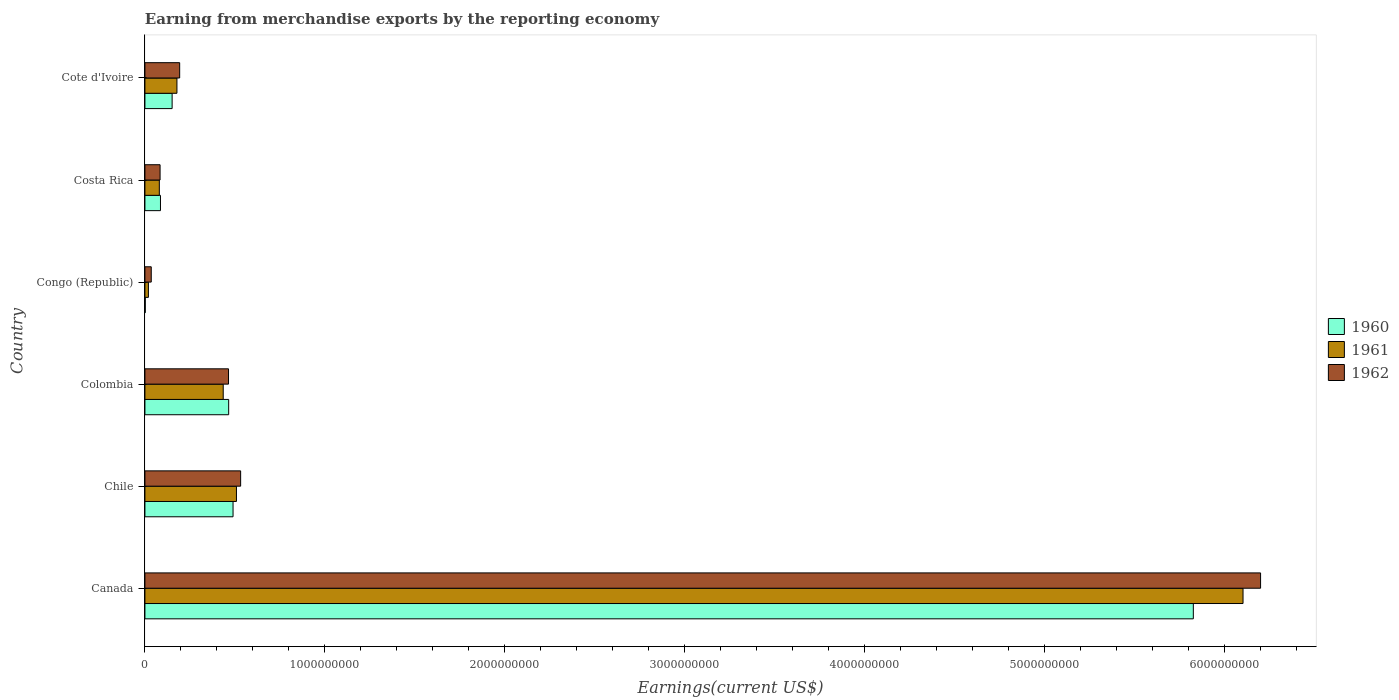How many different coloured bars are there?
Your answer should be very brief. 3. Are the number of bars on each tick of the Y-axis equal?
Give a very brief answer. Yes. How many bars are there on the 3rd tick from the bottom?
Keep it short and to the point. 3. What is the label of the 6th group of bars from the top?
Your answer should be compact. Canada. In how many cases, is the number of bars for a given country not equal to the number of legend labels?
Your response must be concise. 0. What is the amount earned from merchandise exports in 1960 in Cote d'Ivoire?
Make the answer very short. 1.51e+08. Across all countries, what is the maximum amount earned from merchandise exports in 1961?
Make the answer very short. 6.10e+09. Across all countries, what is the minimum amount earned from merchandise exports in 1960?
Provide a short and direct response. 1.90e+06. In which country was the amount earned from merchandise exports in 1960 maximum?
Keep it short and to the point. Canada. In which country was the amount earned from merchandise exports in 1961 minimum?
Your response must be concise. Congo (Republic). What is the total amount earned from merchandise exports in 1961 in the graph?
Give a very brief answer. 7.32e+09. What is the difference between the amount earned from merchandise exports in 1960 in Chile and that in Congo (Republic)?
Ensure brevity in your answer.  4.88e+08. What is the difference between the amount earned from merchandise exports in 1962 in Chile and the amount earned from merchandise exports in 1961 in Colombia?
Your answer should be very brief. 9.68e+07. What is the average amount earned from merchandise exports in 1961 per country?
Your response must be concise. 1.22e+09. What is the difference between the amount earned from merchandise exports in 1962 and amount earned from merchandise exports in 1961 in Congo (Republic)?
Offer a terse response. 1.58e+07. In how many countries, is the amount earned from merchandise exports in 1960 greater than 5000000000 US$?
Provide a succinct answer. 1. What is the ratio of the amount earned from merchandise exports in 1961 in Chile to that in Congo (Republic)?
Offer a terse response. 26.22. Is the difference between the amount earned from merchandise exports in 1962 in Chile and Costa Rica greater than the difference between the amount earned from merchandise exports in 1961 in Chile and Costa Rica?
Your answer should be very brief. Yes. What is the difference between the highest and the second highest amount earned from merchandise exports in 1962?
Your answer should be very brief. 5.67e+09. What is the difference between the highest and the lowest amount earned from merchandise exports in 1962?
Provide a succinct answer. 6.16e+09. Is the sum of the amount earned from merchandise exports in 1960 in Chile and Colombia greater than the maximum amount earned from merchandise exports in 1961 across all countries?
Keep it short and to the point. No. What does the 3rd bar from the bottom in Costa Rica represents?
Your answer should be compact. 1962. How many bars are there?
Your answer should be very brief. 18. Are all the bars in the graph horizontal?
Offer a terse response. Yes. Are the values on the major ticks of X-axis written in scientific E-notation?
Keep it short and to the point. No. Does the graph contain grids?
Keep it short and to the point. No. How many legend labels are there?
Make the answer very short. 3. What is the title of the graph?
Provide a short and direct response. Earning from merchandise exports by the reporting economy. What is the label or title of the X-axis?
Your answer should be compact. Earnings(current US$). What is the label or title of the Y-axis?
Provide a short and direct response. Country. What is the Earnings(current US$) in 1960 in Canada?
Ensure brevity in your answer.  5.83e+09. What is the Earnings(current US$) in 1961 in Canada?
Make the answer very short. 6.10e+09. What is the Earnings(current US$) in 1962 in Canada?
Offer a terse response. 6.20e+09. What is the Earnings(current US$) in 1960 in Chile?
Offer a very short reply. 4.90e+08. What is the Earnings(current US$) in 1961 in Chile?
Your answer should be very brief. 5.09e+08. What is the Earnings(current US$) of 1962 in Chile?
Provide a short and direct response. 5.32e+08. What is the Earnings(current US$) in 1960 in Colombia?
Your answer should be compact. 4.65e+08. What is the Earnings(current US$) in 1961 in Colombia?
Your response must be concise. 4.35e+08. What is the Earnings(current US$) of 1962 in Colombia?
Make the answer very short. 4.64e+08. What is the Earnings(current US$) of 1960 in Congo (Republic)?
Your answer should be very brief. 1.90e+06. What is the Earnings(current US$) in 1961 in Congo (Republic)?
Offer a very short reply. 1.94e+07. What is the Earnings(current US$) of 1962 in Congo (Republic)?
Offer a terse response. 3.52e+07. What is the Earnings(current US$) of 1960 in Costa Rica?
Provide a succinct answer. 8.64e+07. What is the Earnings(current US$) in 1961 in Costa Rica?
Your answer should be compact. 8.01e+07. What is the Earnings(current US$) in 1962 in Costa Rica?
Keep it short and to the point. 8.42e+07. What is the Earnings(current US$) of 1960 in Cote d'Ivoire?
Provide a succinct answer. 1.51e+08. What is the Earnings(current US$) of 1961 in Cote d'Ivoire?
Provide a short and direct response. 1.78e+08. What is the Earnings(current US$) in 1962 in Cote d'Ivoire?
Provide a short and direct response. 1.93e+08. Across all countries, what is the maximum Earnings(current US$) of 1960?
Your answer should be very brief. 5.83e+09. Across all countries, what is the maximum Earnings(current US$) in 1961?
Ensure brevity in your answer.  6.10e+09. Across all countries, what is the maximum Earnings(current US$) in 1962?
Provide a short and direct response. 6.20e+09. Across all countries, what is the minimum Earnings(current US$) in 1960?
Ensure brevity in your answer.  1.90e+06. Across all countries, what is the minimum Earnings(current US$) of 1961?
Provide a succinct answer. 1.94e+07. Across all countries, what is the minimum Earnings(current US$) in 1962?
Provide a short and direct response. 3.52e+07. What is the total Earnings(current US$) of 1960 in the graph?
Your response must be concise. 7.02e+09. What is the total Earnings(current US$) in 1961 in the graph?
Ensure brevity in your answer.  7.32e+09. What is the total Earnings(current US$) in 1962 in the graph?
Keep it short and to the point. 7.51e+09. What is the difference between the Earnings(current US$) in 1960 in Canada and that in Chile?
Provide a succinct answer. 5.34e+09. What is the difference between the Earnings(current US$) of 1961 in Canada and that in Chile?
Offer a terse response. 5.59e+09. What is the difference between the Earnings(current US$) in 1962 in Canada and that in Chile?
Give a very brief answer. 5.67e+09. What is the difference between the Earnings(current US$) of 1960 in Canada and that in Colombia?
Ensure brevity in your answer.  5.36e+09. What is the difference between the Earnings(current US$) in 1961 in Canada and that in Colombia?
Offer a very short reply. 5.67e+09. What is the difference between the Earnings(current US$) of 1962 in Canada and that in Colombia?
Your answer should be very brief. 5.73e+09. What is the difference between the Earnings(current US$) in 1960 in Canada and that in Congo (Republic)?
Make the answer very short. 5.82e+09. What is the difference between the Earnings(current US$) in 1961 in Canada and that in Congo (Republic)?
Provide a short and direct response. 6.08e+09. What is the difference between the Earnings(current US$) of 1962 in Canada and that in Congo (Republic)?
Give a very brief answer. 6.16e+09. What is the difference between the Earnings(current US$) in 1960 in Canada and that in Costa Rica?
Your response must be concise. 5.74e+09. What is the difference between the Earnings(current US$) of 1961 in Canada and that in Costa Rica?
Offer a very short reply. 6.02e+09. What is the difference between the Earnings(current US$) in 1962 in Canada and that in Costa Rica?
Ensure brevity in your answer.  6.11e+09. What is the difference between the Earnings(current US$) of 1960 in Canada and that in Cote d'Ivoire?
Make the answer very short. 5.67e+09. What is the difference between the Earnings(current US$) of 1961 in Canada and that in Cote d'Ivoire?
Your answer should be compact. 5.92e+09. What is the difference between the Earnings(current US$) in 1962 in Canada and that in Cote d'Ivoire?
Give a very brief answer. 6.01e+09. What is the difference between the Earnings(current US$) in 1960 in Chile and that in Colombia?
Give a very brief answer. 2.43e+07. What is the difference between the Earnings(current US$) in 1961 in Chile and that in Colombia?
Offer a very short reply. 7.35e+07. What is the difference between the Earnings(current US$) in 1962 in Chile and that in Colombia?
Provide a short and direct response. 6.74e+07. What is the difference between the Earnings(current US$) of 1960 in Chile and that in Congo (Republic)?
Provide a succinct answer. 4.88e+08. What is the difference between the Earnings(current US$) of 1961 in Chile and that in Congo (Republic)?
Offer a terse response. 4.89e+08. What is the difference between the Earnings(current US$) of 1962 in Chile and that in Congo (Republic)?
Give a very brief answer. 4.97e+08. What is the difference between the Earnings(current US$) of 1960 in Chile and that in Costa Rica?
Keep it short and to the point. 4.03e+08. What is the difference between the Earnings(current US$) of 1961 in Chile and that in Costa Rica?
Make the answer very short. 4.28e+08. What is the difference between the Earnings(current US$) of 1962 in Chile and that in Costa Rica?
Your answer should be compact. 4.48e+08. What is the difference between the Earnings(current US$) of 1960 in Chile and that in Cote d'Ivoire?
Keep it short and to the point. 3.39e+08. What is the difference between the Earnings(current US$) of 1961 in Chile and that in Cote d'Ivoire?
Keep it short and to the point. 3.31e+08. What is the difference between the Earnings(current US$) of 1962 in Chile and that in Cote d'Ivoire?
Your answer should be very brief. 3.39e+08. What is the difference between the Earnings(current US$) in 1960 in Colombia and that in Congo (Republic)?
Your answer should be compact. 4.64e+08. What is the difference between the Earnings(current US$) in 1961 in Colombia and that in Congo (Republic)?
Provide a short and direct response. 4.16e+08. What is the difference between the Earnings(current US$) of 1962 in Colombia and that in Congo (Republic)?
Your answer should be very brief. 4.29e+08. What is the difference between the Earnings(current US$) in 1960 in Colombia and that in Costa Rica?
Provide a succinct answer. 3.79e+08. What is the difference between the Earnings(current US$) of 1961 in Colombia and that in Costa Rica?
Provide a short and direct response. 3.55e+08. What is the difference between the Earnings(current US$) of 1962 in Colombia and that in Costa Rica?
Ensure brevity in your answer.  3.80e+08. What is the difference between the Earnings(current US$) of 1960 in Colombia and that in Cote d'Ivoire?
Offer a terse response. 3.14e+08. What is the difference between the Earnings(current US$) in 1961 in Colombia and that in Cote d'Ivoire?
Keep it short and to the point. 2.57e+08. What is the difference between the Earnings(current US$) of 1962 in Colombia and that in Cote d'Ivoire?
Offer a very short reply. 2.71e+08. What is the difference between the Earnings(current US$) of 1960 in Congo (Republic) and that in Costa Rica?
Give a very brief answer. -8.45e+07. What is the difference between the Earnings(current US$) in 1961 in Congo (Republic) and that in Costa Rica?
Your response must be concise. -6.07e+07. What is the difference between the Earnings(current US$) of 1962 in Congo (Republic) and that in Costa Rica?
Provide a short and direct response. -4.90e+07. What is the difference between the Earnings(current US$) in 1960 in Congo (Republic) and that in Cote d'Ivoire?
Your answer should be compact. -1.49e+08. What is the difference between the Earnings(current US$) in 1961 in Congo (Republic) and that in Cote d'Ivoire?
Offer a very short reply. -1.58e+08. What is the difference between the Earnings(current US$) of 1962 in Congo (Republic) and that in Cote d'Ivoire?
Keep it short and to the point. -1.58e+08. What is the difference between the Earnings(current US$) in 1960 in Costa Rica and that in Cote d'Ivoire?
Ensure brevity in your answer.  -6.48e+07. What is the difference between the Earnings(current US$) of 1961 in Costa Rica and that in Cote d'Ivoire?
Provide a short and direct response. -9.78e+07. What is the difference between the Earnings(current US$) in 1962 in Costa Rica and that in Cote d'Ivoire?
Keep it short and to the point. -1.09e+08. What is the difference between the Earnings(current US$) of 1960 in Canada and the Earnings(current US$) of 1961 in Chile?
Give a very brief answer. 5.32e+09. What is the difference between the Earnings(current US$) in 1960 in Canada and the Earnings(current US$) in 1962 in Chile?
Offer a very short reply. 5.29e+09. What is the difference between the Earnings(current US$) of 1961 in Canada and the Earnings(current US$) of 1962 in Chile?
Provide a short and direct response. 5.57e+09. What is the difference between the Earnings(current US$) of 1960 in Canada and the Earnings(current US$) of 1961 in Colombia?
Give a very brief answer. 5.39e+09. What is the difference between the Earnings(current US$) in 1960 in Canada and the Earnings(current US$) in 1962 in Colombia?
Provide a short and direct response. 5.36e+09. What is the difference between the Earnings(current US$) of 1961 in Canada and the Earnings(current US$) of 1962 in Colombia?
Your answer should be very brief. 5.64e+09. What is the difference between the Earnings(current US$) in 1960 in Canada and the Earnings(current US$) in 1961 in Congo (Republic)?
Make the answer very short. 5.81e+09. What is the difference between the Earnings(current US$) in 1960 in Canada and the Earnings(current US$) in 1962 in Congo (Republic)?
Your response must be concise. 5.79e+09. What is the difference between the Earnings(current US$) in 1961 in Canada and the Earnings(current US$) in 1962 in Congo (Republic)?
Your answer should be very brief. 6.07e+09. What is the difference between the Earnings(current US$) of 1960 in Canada and the Earnings(current US$) of 1961 in Costa Rica?
Give a very brief answer. 5.75e+09. What is the difference between the Earnings(current US$) of 1960 in Canada and the Earnings(current US$) of 1962 in Costa Rica?
Offer a terse response. 5.74e+09. What is the difference between the Earnings(current US$) of 1961 in Canada and the Earnings(current US$) of 1962 in Costa Rica?
Offer a terse response. 6.02e+09. What is the difference between the Earnings(current US$) in 1960 in Canada and the Earnings(current US$) in 1961 in Cote d'Ivoire?
Your response must be concise. 5.65e+09. What is the difference between the Earnings(current US$) in 1960 in Canada and the Earnings(current US$) in 1962 in Cote d'Ivoire?
Your answer should be compact. 5.63e+09. What is the difference between the Earnings(current US$) in 1961 in Canada and the Earnings(current US$) in 1962 in Cote d'Ivoire?
Keep it short and to the point. 5.91e+09. What is the difference between the Earnings(current US$) of 1960 in Chile and the Earnings(current US$) of 1961 in Colombia?
Your answer should be very brief. 5.46e+07. What is the difference between the Earnings(current US$) in 1960 in Chile and the Earnings(current US$) in 1962 in Colombia?
Ensure brevity in your answer.  2.52e+07. What is the difference between the Earnings(current US$) in 1961 in Chile and the Earnings(current US$) in 1962 in Colombia?
Your answer should be very brief. 4.41e+07. What is the difference between the Earnings(current US$) in 1960 in Chile and the Earnings(current US$) in 1961 in Congo (Republic)?
Provide a short and direct response. 4.70e+08. What is the difference between the Earnings(current US$) of 1960 in Chile and the Earnings(current US$) of 1962 in Congo (Republic)?
Offer a terse response. 4.54e+08. What is the difference between the Earnings(current US$) in 1961 in Chile and the Earnings(current US$) in 1962 in Congo (Republic)?
Ensure brevity in your answer.  4.73e+08. What is the difference between the Earnings(current US$) of 1960 in Chile and the Earnings(current US$) of 1961 in Costa Rica?
Your response must be concise. 4.10e+08. What is the difference between the Earnings(current US$) of 1960 in Chile and the Earnings(current US$) of 1962 in Costa Rica?
Make the answer very short. 4.06e+08. What is the difference between the Earnings(current US$) in 1961 in Chile and the Earnings(current US$) in 1962 in Costa Rica?
Ensure brevity in your answer.  4.24e+08. What is the difference between the Earnings(current US$) of 1960 in Chile and the Earnings(current US$) of 1961 in Cote d'Ivoire?
Your answer should be very brief. 3.12e+08. What is the difference between the Earnings(current US$) in 1960 in Chile and the Earnings(current US$) in 1962 in Cote d'Ivoire?
Keep it short and to the point. 2.97e+08. What is the difference between the Earnings(current US$) in 1961 in Chile and the Earnings(current US$) in 1962 in Cote d'Ivoire?
Ensure brevity in your answer.  3.16e+08. What is the difference between the Earnings(current US$) in 1960 in Colombia and the Earnings(current US$) in 1961 in Congo (Republic)?
Your answer should be very brief. 4.46e+08. What is the difference between the Earnings(current US$) in 1960 in Colombia and the Earnings(current US$) in 1962 in Congo (Republic)?
Provide a succinct answer. 4.30e+08. What is the difference between the Earnings(current US$) in 1961 in Colombia and the Earnings(current US$) in 1962 in Congo (Republic)?
Offer a terse response. 4.00e+08. What is the difference between the Earnings(current US$) of 1960 in Colombia and the Earnings(current US$) of 1961 in Costa Rica?
Provide a short and direct response. 3.85e+08. What is the difference between the Earnings(current US$) of 1960 in Colombia and the Earnings(current US$) of 1962 in Costa Rica?
Make the answer very short. 3.81e+08. What is the difference between the Earnings(current US$) of 1961 in Colombia and the Earnings(current US$) of 1962 in Costa Rica?
Make the answer very short. 3.51e+08. What is the difference between the Earnings(current US$) in 1960 in Colombia and the Earnings(current US$) in 1961 in Cote d'Ivoire?
Give a very brief answer. 2.88e+08. What is the difference between the Earnings(current US$) of 1960 in Colombia and the Earnings(current US$) of 1962 in Cote d'Ivoire?
Provide a succinct answer. 2.72e+08. What is the difference between the Earnings(current US$) in 1961 in Colombia and the Earnings(current US$) in 1962 in Cote d'Ivoire?
Make the answer very short. 2.42e+08. What is the difference between the Earnings(current US$) of 1960 in Congo (Republic) and the Earnings(current US$) of 1961 in Costa Rica?
Give a very brief answer. -7.82e+07. What is the difference between the Earnings(current US$) in 1960 in Congo (Republic) and the Earnings(current US$) in 1962 in Costa Rica?
Provide a succinct answer. -8.23e+07. What is the difference between the Earnings(current US$) of 1961 in Congo (Republic) and the Earnings(current US$) of 1962 in Costa Rica?
Your answer should be compact. -6.48e+07. What is the difference between the Earnings(current US$) of 1960 in Congo (Republic) and the Earnings(current US$) of 1961 in Cote d'Ivoire?
Your answer should be very brief. -1.76e+08. What is the difference between the Earnings(current US$) of 1960 in Congo (Republic) and the Earnings(current US$) of 1962 in Cote d'Ivoire?
Keep it short and to the point. -1.91e+08. What is the difference between the Earnings(current US$) of 1961 in Congo (Republic) and the Earnings(current US$) of 1962 in Cote d'Ivoire?
Your answer should be compact. -1.74e+08. What is the difference between the Earnings(current US$) in 1960 in Costa Rica and the Earnings(current US$) in 1961 in Cote d'Ivoire?
Keep it short and to the point. -9.15e+07. What is the difference between the Earnings(current US$) of 1960 in Costa Rica and the Earnings(current US$) of 1962 in Cote d'Ivoire?
Provide a short and direct response. -1.07e+08. What is the difference between the Earnings(current US$) in 1961 in Costa Rica and the Earnings(current US$) in 1962 in Cote d'Ivoire?
Provide a short and direct response. -1.13e+08. What is the average Earnings(current US$) of 1960 per country?
Provide a succinct answer. 1.17e+09. What is the average Earnings(current US$) of 1961 per country?
Make the answer very short. 1.22e+09. What is the average Earnings(current US$) of 1962 per country?
Provide a short and direct response. 1.25e+09. What is the difference between the Earnings(current US$) in 1960 and Earnings(current US$) in 1961 in Canada?
Keep it short and to the point. -2.76e+08. What is the difference between the Earnings(current US$) in 1960 and Earnings(current US$) in 1962 in Canada?
Offer a terse response. -3.74e+08. What is the difference between the Earnings(current US$) of 1961 and Earnings(current US$) of 1962 in Canada?
Keep it short and to the point. -9.75e+07. What is the difference between the Earnings(current US$) of 1960 and Earnings(current US$) of 1961 in Chile?
Your answer should be very brief. -1.89e+07. What is the difference between the Earnings(current US$) of 1960 and Earnings(current US$) of 1962 in Chile?
Your answer should be compact. -4.22e+07. What is the difference between the Earnings(current US$) in 1961 and Earnings(current US$) in 1962 in Chile?
Your response must be concise. -2.33e+07. What is the difference between the Earnings(current US$) in 1960 and Earnings(current US$) in 1961 in Colombia?
Make the answer very short. 3.03e+07. What is the difference between the Earnings(current US$) of 1961 and Earnings(current US$) of 1962 in Colombia?
Your answer should be compact. -2.94e+07. What is the difference between the Earnings(current US$) of 1960 and Earnings(current US$) of 1961 in Congo (Republic)?
Your response must be concise. -1.75e+07. What is the difference between the Earnings(current US$) in 1960 and Earnings(current US$) in 1962 in Congo (Republic)?
Keep it short and to the point. -3.33e+07. What is the difference between the Earnings(current US$) in 1961 and Earnings(current US$) in 1962 in Congo (Republic)?
Ensure brevity in your answer.  -1.58e+07. What is the difference between the Earnings(current US$) of 1960 and Earnings(current US$) of 1961 in Costa Rica?
Offer a very short reply. 6.30e+06. What is the difference between the Earnings(current US$) of 1960 and Earnings(current US$) of 1962 in Costa Rica?
Your response must be concise. 2.20e+06. What is the difference between the Earnings(current US$) in 1961 and Earnings(current US$) in 1962 in Costa Rica?
Make the answer very short. -4.10e+06. What is the difference between the Earnings(current US$) in 1960 and Earnings(current US$) in 1961 in Cote d'Ivoire?
Provide a short and direct response. -2.67e+07. What is the difference between the Earnings(current US$) of 1960 and Earnings(current US$) of 1962 in Cote d'Ivoire?
Provide a succinct answer. -4.19e+07. What is the difference between the Earnings(current US$) of 1961 and Earnings(current US$) of 1962 in Cote d'Ivoire?
Your answer should be compact. -1.52e+07. What is the ratio of the Earnings(current US$) in 1960 in Canada to that in Chile?
Provide a succinct answer. 11.9. What is the ratio of the Earnings(current US$) of 1961 in Canada to that in Chile?
Your answer should be compact. 12. What is the ratio of the Earnings(current US$) in 1962 in Canada to that in Chile?
Ensure brevity in your answer.  11.65. What is the ratio of the Earnings(current US$) in 1960 in Canada to that in Colombia?
Ensure brevity in your answer.  12.52. What is the ratio of the Earnings(current US$) of 1961 in Canada to that in Colombia?
Your response must be concise. 14.02. What is the ratio of the Earnings(current US$) of 1962 in Canada to that in Colombia?
Your response must be concise. 13.35. What is the ratio of the Earnings(current US$) of 1960 in Canada to that in Congo (Republic)?
Your answer should be compact. 3066. What is the ratio of the Earnings(current US$) in 1961 in Canada to that in Congo (Republic)?
Ensure brevity in your answer.  314.52. What is the ratio of the Earnings(current US$) in 1962 in Canada to that in Congo (Republic)?
Your answer should be compact. 176.11. What is the ratio of the Earnings(current US$) in 1960 in Canada to that in Costa Rica?
Offer a very short reply. 67.42. What is the ratio of the Earnings(current US$) in 1961 in Canada to that in Costa Rica?
Offer a very short reply. 76.17. What is the ratio of the Earnings(current US$) in 1962 in Canada to that in Costa Rica?
Provide a succinct answer. 73.62. What is the ratio of the Earnings(current US$) in 1960 in Canada to that in Cote d'Ivoire?
Give a very brief answer. 38.53. What is the ratio of the Earnings(current US$) in 1961 in Canada to that in Cote d'Ivoire?
Offer a terse response. 34.3. What is the ratio of the Earnings(current US$) of 1962 in Canada to that in Cote d'Ivoire?
Keep it short and to the point. 32.1. What is the ratio of the Earnings(current US$) in 1960 in Chile to that in Colombia?
Your response must be concise. 1.05. What is the ratio of the Earnings(current US$) of 1961 in Chile to that in Colombia?
Give a very brief answer. 1.17. What is the ratio of the Earnings(current US$) in 1962 in Chile to that in Colombia?
Offer a very short reply. 1.15. What is the ratio of the Earnings(current US$) of 1960 in Chile to that in Congo (Republic)?
Give a very brief answer. 257.74. What is the ratio of the Earnings(current US$) in 1961 in Chile to that in Congo (Republic)?
Keep it short and to the point. 26.22. What is the ratio of the Earnings(current US$) in 1962 in Chile to that in Congo (Republic)?
Offer a very short reply. 15.11. What is the ratio of the Earnings(current US$) in 1960 in Chile to that in Costa Rica?
Provide a succinct answer. 5.67. What is the ratio of the Earnings(current US$) of 1961 in Chile to that in Costa Rica?
Offer a very short reply. 6.35. What is the ratio of the Earnings(current US$) of 1962 in Chile to that in Costa Rica?
Your answer should be compact. 6.32. What is the ratio of the Earnings(current US$) of 1960 in Chile to that in Cote d'Ivoire?
Your answer should be very brief. 3.24. What is the ratio of the Earnings(current US$) of 1961 in Chile to that in Cote d'Ivoire?
Provide a short and direct response. 2.86. What is the ratio of the Earnings(current US$) of 1962 in Chile to that in Cote d'Ivoire?
Provide a succinct answer. 2.75. What is the ratio of the Earnings(current US$) of 1960 in Colombia to that in Congo (Republic)?
Your answer should be compact. 244.95. What is the ratio of the Earnings(current US$) in 1961 in Colombia to that in Congo (Republic)?
Give a very brief answer. 22.43. What is the ratio of the Earnings(current US$) of 1962 in Colombia to that in Congo (Republic)?
Provide a short and direct response. 13.2. What is the ratio of the Earnings(current US$) in 1960 in Colombia to that in Costa Rica?
Provide a short and direct response. 5.39. What is the ratio of the Earnings(current US$) of 1961 in Colombia to that in Costa Rica?
Give a very brief answer. 5.43. What is the ratio of the Earnings(current US$) of 1962 in Colombia to that in Costa Rica?
Make the answer very short. 5.52. What is the ratio of the Earnings(current US$) in 1960 in Colombia to that in Cote d'Ivoire?
Give a very brief answer. 3.08. What is the ratio of the Earnings(current US$) in 1961 in Colombia to that in Cote d'Ivoire?
Your answer should be very brief. 2.45. What is the ratio of the Earnings(current US$) of 1962 in Colombia to that in Cote d'Ivoire?
Give a very brief answer. 2.41. What is the ratio of the Earnings(current US$) of 1960 in Congo (Republic) to that in Costa Rica?
Your answer should be compact. 0.02. What is the ratio of the Earnings(current US$) in 1961 in Congo (Republic) to that in Costa Rica?
Offer a very short reply. 0.24. What is the ratio of the Earnings(current US$) in 1962 in Congo (Republic) to that in Costa Rica?
Keep it short and to the point. 0.42. What is the ratio of the Earnings(current US$) of 1960 in Congo (Republic) to that in Cote d'Ivoire?
Provide a short and direct response. 0.01. What is the ratio of the Earnings(current US$) in 1961 in Congo (Republic) to that in Cote d'Ivoire?
Offer a terse response. 0.11. What is the ratio of the Earnings(current US$) in 1962 in Congo (Republic) to that in Cote d'Ivoire?
Your answer should be very brief. 0.18. What is the ratio of the Earnings(current US$) in 1960 in Costa Rica to that in Cote d'Ivoire?
Keep it short and to the point. 0.57. What is the ratio of the Earnings(current US$) of 1961 in Costa Rica to that in Cote d'Ivoire?
Offer a terse response. 0.45. What is the ratio of the Earnings(current US$) in 1962 in Costa Rica to that in Cote d'Ivoire?
Keep it short and to the point. 0.44. What is the difference between the highest and the second highest Earnings(current US$) of 1960?
Provide a short and direct response. 5.34e+09. What is the difference between the highest and the second highest Earnings(current US$) in 1961?
Ensure brevity in your answer.  5.59e+09. What is the difference between the highest and the second highest Earnings(current US$) in 1962?
Provide a succinct answer. 5.67e+09. What is the difference between the highest and the lowest Earnings(current US$) in 1960?
Provide a short and direct response. 5.82e+09. What is the difference between the highest and the lowest Earnings(current US$) of 1961?
Ensure brevity in your answer.  6.08e+09. What is the difference between the highest and the lowest Earnings(current US$) in 1962?
Make the answer very short. 6.16e+09. 